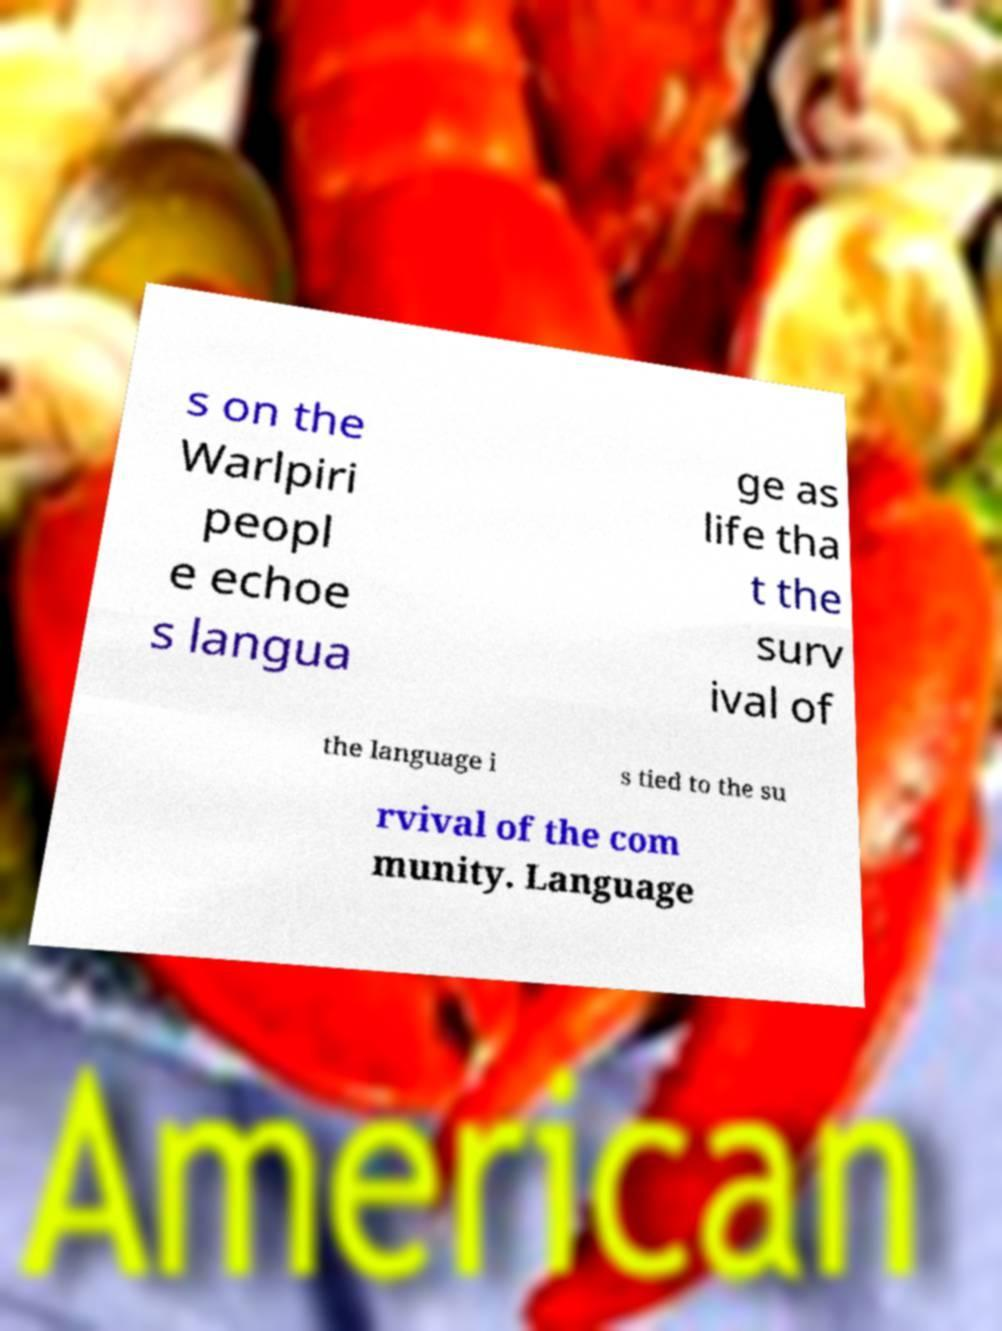Can you accurately transcribe the text from the provided image for me? s on the Warlpiri peopl e echoe s langua ge as life tha t the surv ival of the language i s tied to the su rvival of the com munity. Language 